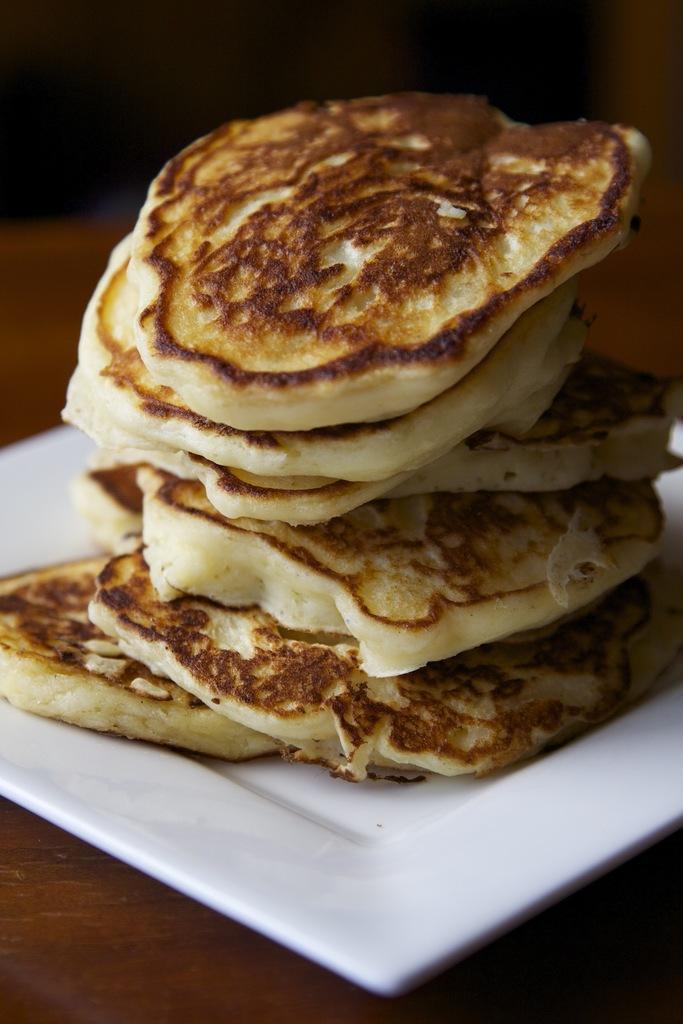In one or two sentences, can you explain what this image depicts? In this picture I can see food items on a white color tray. This tray is on a surface. 